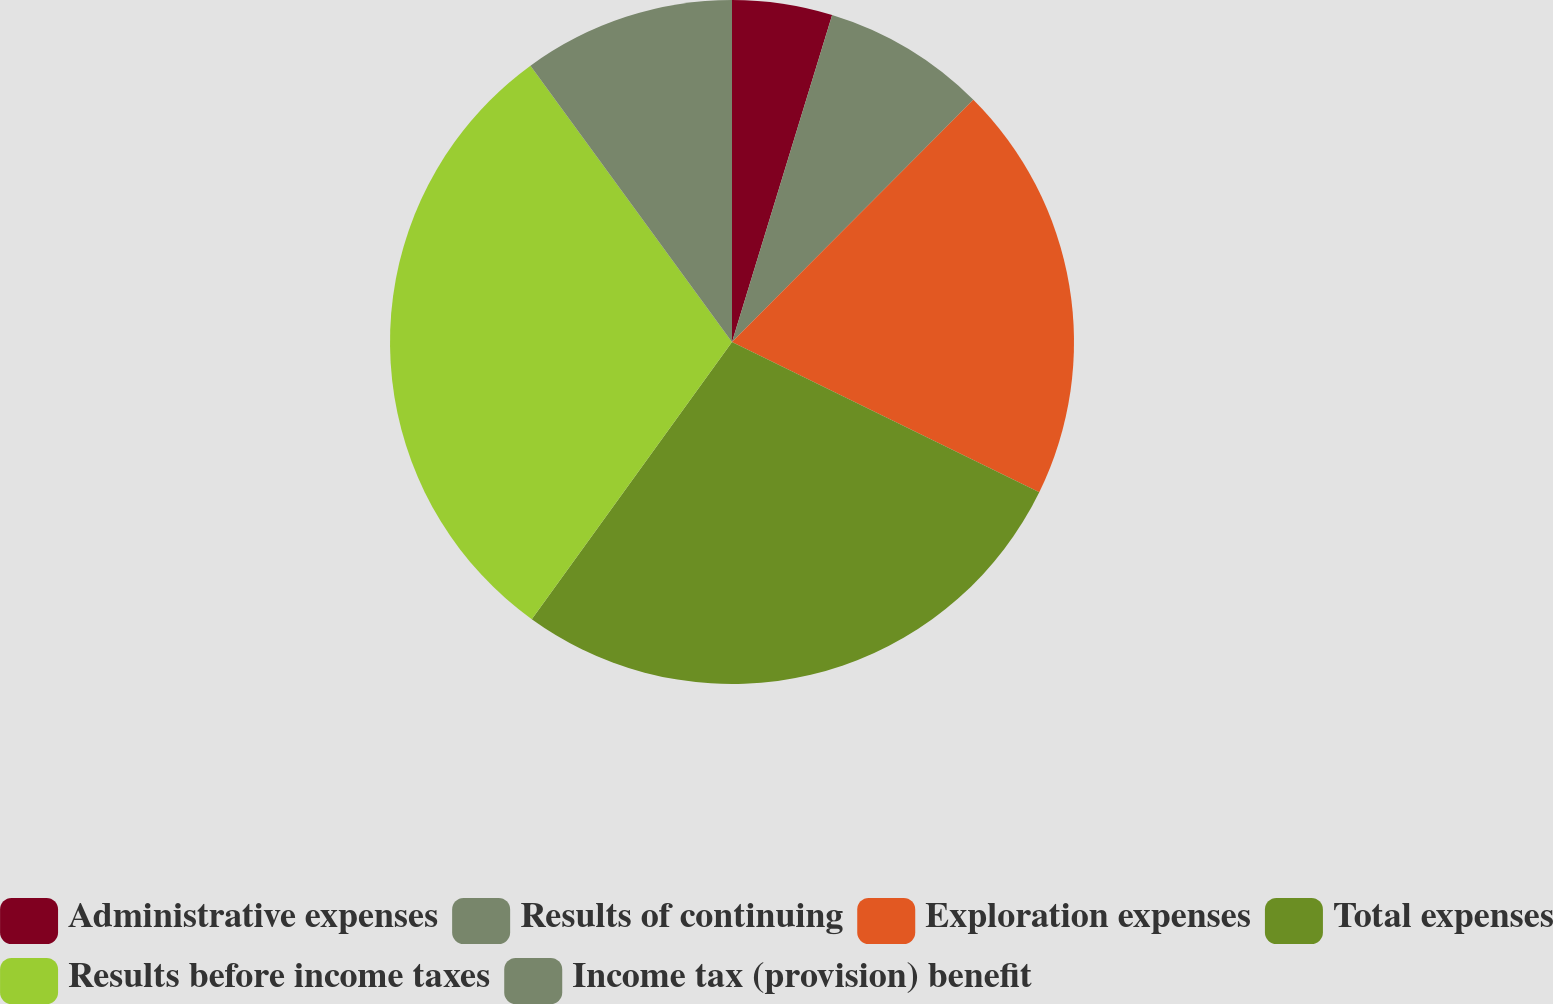Convert chart. <chart><loc_0><loc_0><loc_500><loc_500><pie_chart><fcel>Administrative expenses<fcel>Results of continuing<fcel>Exploration expenses<fcel>Total expenses<fcel>Results before income taxes<fcel>Income tax (provision) benefit<nl><fcel>4.73%<fcel>7.74%<fcel>19.77%<fcel>27.72%<fcel>30.02%<fcel>10.03%<nl></chart> 